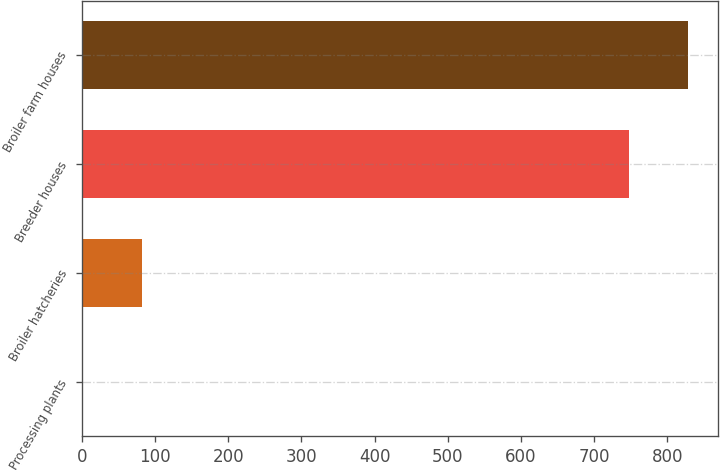Convert chart. <chart><loc_0><loc_0><loc_500><loc_500><bar_chart><fcel>Processing plants<fcel>Broiler hatcheries<fcel>Breeder houses<fcel>Broiler farm houses<nl><fcel>2<fcel>83<fcel>747<fcel>828<nl></chart> 